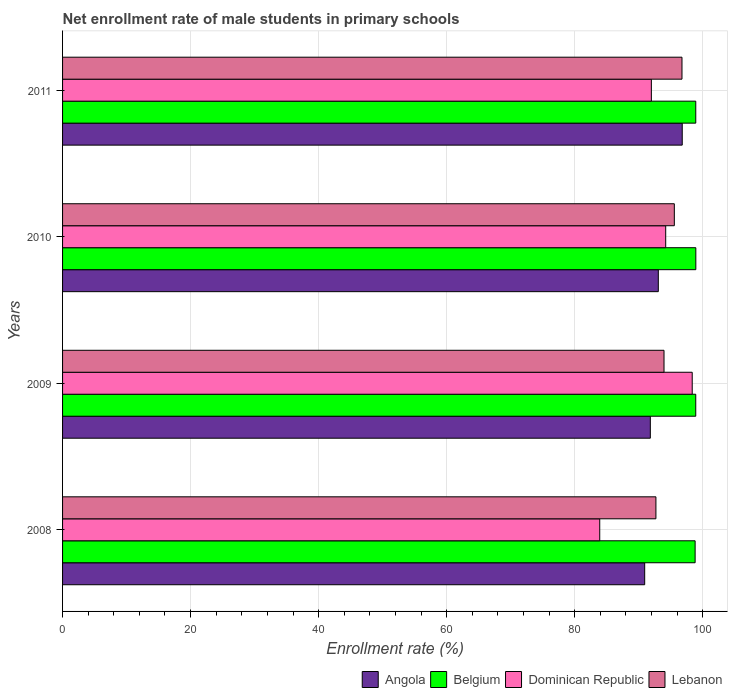How many different coloured bars are there?
Ensure brevity in your answer.  4. Are the number of bars per tick equal to the number of legend labels?
Give a very brief answer. Yes. Are the number of bars on each tick of the Y-axis equal?
Your answer should be compact. Yes. How many bars are there on the 1st tick from the top?
Your answer should be very brief. 4. What is the label of the 4th group of bars from the top?
Ensure brevity in your answer.  2008. In how many cases, is the number of bars for a given year not equal to the number of legend labels?
Ensure brevity in your answer.  0. What is the net enrollment rate of male students in primary schools in Dominican Republic in 2011?
Keep it short and to the point. 91.98. Across all years, what is the maximum net enrollment rate of male students in primary schools in Belgium?
Keep it short and to the point. 98.92. Across all years, what is the minimum net enrollment rate of male students in primary schools in Lebanon?
Your answer should be compact. 92.69. What is the total net enrollment rate of male students in primary schools in Belgium in the graph?
Keep it short and to the point. 395.57. What is the difference between the net enrollment rate of male students in primary schools in Angola in 2009 and that in 2010?
Your response must be concise. -1.25. What is the difference between the net enrollment rate of male students in primary schools in Dominican Republic in 2010 and the net enrollment rate of male students in primary schools in Belgium in 2009?
Keep it short and to the point. -4.69. What is the average net enrollment rate of male students in primary schools in Dominican Republic per year?
Keep it short and to the point. 92.12. In the year 2011, what is the difference between the net enrollment rate of male students in primary schools in Lebanon and net enrollment rate of male students in primary schools in Angola?
Offer a very short reply. -0.04. In how many years, is the net enrollment rate of male students in primary schools in Lebanon greater than 4 %?
Make the answer very short. 4. What is the ratio of the net enrollment rate of male students in primary schools in Dominican Republic in 2008 to that in 2010?
Your answer should be compact. 0.89. What is the difference between the highest and the second highest net enrollment rate of male students in primary schools in Angola?
Give a very brief answer. 3.74. What is the difference between the highest and the lowest net enrollment rate of male students in primary schools in Lebanon?
Give a very brief answer. 4.07. Is the sum of the net enrollment rate of male students in primary schools in Dominican Republic in 2009 and 2011 greater than the maximum net enrollment rate of male students in primary schools in Angola across all years?
Offer a terse response. Yes. What does the 3rd bar from the top in 2011 represents?
Make the answer very short. Belgium. What does the 3rd bar from the bottom in 2008 represents?
Offer a very short reply. Dominican Republic. How many bars are there?
Offer a very short reply. 16. How many years are there in the graph?
Provide a short and direct response. 4. Does the graph contain any zero values?
Ensure brevity in your answer.  No. How are the legend labels stacked?
Your answer should be very brief. Horizontal. What is the title of the graph?
Provide a short and direct response. Net enrollment rate of male students in primary schools. What is the label or title of the X-axis?
Provide a succinct answer. Enrollment rate (%). What is the label or title of the Y-axis?
Keep it short and to the point. Years. What is the Enrollment rate (%) of Angola in 2008?
Offer a very short reply. 90.94. What is the Enrollment rate (%) in Belgium in 2008?
Your answer should be very brief. 98.81. What is the Enrollment rate (%) of Dominican Republic in 2008?
Provide a short and direct response. 83.91. What is the Enrollment rate (%) in Lebanon in 2008?
Your answer should be compact. 92.69. What is the Enrollment rate (%) of Angola in 2009?
Offer a very short reply. 91.82. What is the Enrollment rate (%) of Belgium in 2009?
Your response must be concise. 98.91. What is the Enrollment rate (%) in Dominican Republic in 2009?
Ensure brevity in your answer.  98.36. What is the Enrollment rate (%) of Lebanon in 2009?
Ensure brevity in your answer.  93.96. What is the Enrollment rate (%) of Angola in 2010?
Your answer should be very brief. 93.06. What is the Enrollment rate (%) in Belgium in 2010?
Give a very brief answer. 98.92. What is the Enrollment rate (%) of Dominican Republic in 2010?
Your answer should be compact. 94.22. What is the Enrollment rate (%) in Lebanon in 2010?
Offer a very short reply. 95.56. What is the Enrollment rate (%) in Angola in 2011?
Keep it short and to the point. 96.8. What is the Enrollment rate (%) of Belgium in 2011?
Offer a terse response. 98.91. What is the Enrollment rate (%) in Dominican Republic in 2011?
Offer a very short reply. 91.98. What is the Enrollment rate (%) of Lebanon in 2011?
Provide a succinct answer. 96.76. Across all years, what is the maximum Enrollment rate (%) of Angola?
Offer a very short reply. 96.8. Across all years, what is the maximum Enrollment rate (%) in Belgium?
Offer a terse response. 98.92. Across all years, what is the maximum Enrollment rate (%) of Dominican Republic?
Your answer should be compact. 98.36. Across all years, what is the maximum Enrollment rate (%) in Lebanon?
Provide a succinct answer. 96.76. Across all years, what is the minimum Enrollment rate (%) of Angola?
Make the answer very short. 90.94. Across all years, what is the minimum Enrollment rate (%) in Belgium?
Your response must be concise. 98.81. Across all years, what is the minimum Enrollment rate (%) of Dominican Republic?
Provide a short and direct response. 83.91. Across all years, what is the minimum Enrollment rate (%) in Lebanon?
Offer a very short reply. 92.69. What is the total Enrollment rate (%) of Angola in the graph?
Your response must be concise. 372.62. What is the total Enrollment rate (%) in Belgium in the graph?
Make the answer very short. 395.57. What is the total Enrollment rate (%) of Dominican Republic in the graph?
Provide a succinct answer. 368.47. What is the total Enrollment rate (%) in Lebanon in the graph?
Provide a short and direct response. 378.97. What is the difference between the Enrollment rate (%) of Angola in 2008 and that in 2009?
Provide a short and direct response. -0.88. What is the difference between the Enrollment rate (%) of Belgium in 2008 and that in 2009?
Your response must be concise. -0.1. What is the difference between the Enrollment rate (%) in Dominican Republic in 2008 and that in 2009?
Ensure brevity in your answer.  -14.45. What is the difference between the Enrollment rate (%) in Lebanon in 2008 and that in 2009?
Give a very brief answer. -1.26. What is the difference between the Enrollment rate (%) of Angola in 2008 and that in 2010?
Make the answer very short. -2.13. What is the difference between the Enrollment rate (%) of Belgium in 2008 and that in 2010?
Make the answer very short. -0.11. What is the difference between the Enrollment rate (%) in Dominican Republic in 2008 and that in 2010?
Your response must be concise. -10.31. What is the difference between the Enrollment rate (%) of Lebanon in 2008 and that in 2010?
Offer a very short reply. -2.87. What is the difference between the Enrollment rate (%) of Angola in 2008 and that in 2011?
Your response must be concise. -5.87. What is the difference between the Enrollment rate (%) in Belgium in 2008 and that in 2011?
Provide a succinct answer. -0.1. What is the difference between the Enrollment rate (%) in Dominican Republic in 2008 and that in 2011?
Offer a terse response. -8.07. What is the difference between the Enrollment rate (%) of Lebanon in 2008 and that in 2011?
Keep it short and to the point. -4.07. What is the difference between the Enrollment rate (%) of Angola in 2009 and that in 2010?
Provide a succinct answer. -1.25. What is the difference between the Enrollment rate (%) in Belgium in 2009 and that in 2010?
Your answer should be very brief. -0.01. What is the difference between the Enrollment rate (%) of Dominican Republic in 2009 and that in 2010?
Your answer should be very brief. 4.14. What is the difference between the Enrollment rate (%) of Lebanon in 2009 and that in 2010?
Your answer should be very brief. -1.61. What is the difference between the Enrollment rate (%) in Angola in 2009 and that in 2011?
Ensure brevity in your answer.  -4.98. What is the difference between the Enrollment rate (%) of Belgium in 2009 and that in 2011?
Provide a short and direct response. -0. What is the difference between the Enrollment rate (%) in Dominican Republic in 2009 and that in 2011?
Your answer should be very brief. 6.38. What is the difference between the Enrollment rate (%) of Lebanon in 2009 and that in 2011?
Offer a terse response. -2.81. What is the difference between the Enrollment rate (%) of Angola in 2010 and that in 2011?
Make the answer very short. -3.74. What is the difference between the Enrollment rate (%) of Belgium in 2010 and that in 2011?
Your answer should be compact. 0.01. What is the difference between the Enrollment rate (%) of Dominican Republic in 2010 and that in 2011?
Your answer should be compact. 2.24. What is the difference between the Enrollment rate (%) in Lebanon in 2010 and that in 2011?
Your response must be concise. -1.2. What is the difference between the Enrollment rate (%) of Angola in 2008 and the Enrollment rate (%) of Belgium in 2009?
Your answer should be compact. -7.98. What is the difference between the Enrollment rate (%) in Angola in 2008 and the Enrollment rate (%) in Dominican Republic in 2009?
Give a very brief answer. -7.42. What is the difference between the Enrollment rate (%) of Angola in 2008 and the Enrollment rate (%) of Lebanon in 2009?
Keep it short and to the point. -3.02. What is the difference between the Enrollment rate (%) in Belgium in 2008 and the Enrollment rate (%) in Dominican Republic in 2009?
Provide a short and direct response. 0.45. What is the difference between the Enrollment rate (%) of Belgium in 2008 and the Enrollment rate (%) of Lebanon in 2009?
Provide a short and direct response. 4.86. What is the difference between the Enrollment rate (%) in Dominican Republic in 2008 and the Enrollment rate (%) in Lebanon in 2009?
Make the answer very short. -10.04. What is the difference between the Enrollment rate (%) of Angola in 2008 and the Enrollment rate (%) of Belgium in 2010?
Ensure brevity in your answer.  -7.99. What is the difference between the Enrollment rate (%) in Angola in 2008 and the Enrollment rate (%) in Dominican Republic in 2010?
Your answer should be compact. -3.28. What is the difference between the Enrollment rate (%) of Angola in 2008 and the Enrollment rate (%) of Lebanon in 2010?
Your answer should be very brief. -4.63. What is the difference between the Enrollment rate (%) in Belgium in 2008 and the Enrollment rate (%) in Dominican Republic in 2010?
Provide a short and direct response. 4.6. What is the difference between the Enrollment rate (%) in Belgium in 2008 and the Enrollment rate (%) in Lebanon in 2010?
Keep it short and to the point. 3.25. What is the difference between the Enrollment rate (%) of Dominican Republic in 2008 and the Enrollment rate (%) of Lebanon in 2010?
Ensure brevity in your answer.  -11.65. What is the difference between the Enrollment rate (%) of Angola in 2008 and the Enrollment rate (%) of Belgium in 2011?
Offer a very short reply. -7.98. What is the difference between the Enrollment rate (%) in Angola in 2008 and the Enrollment rate (%) in Dominican Republic in 2011?
Give a very brief answer. -1.04. What is the difference between the Enrollment rate (%) in Angola in 2008 and the Enrollment rate (%) in Lebanon in 2011?
Provide a succinct answer. -5.82. What is the difference between the Enrollment rate (%) of Belgium in 2008 and the Enrollment rate (%) of Dominican Republic in 2011?
Make the answer very short. 6.84. What is the difference between the Enrollment rate (%) in Belgium in 2008 and the Enrollment rate (%) in Lebanon in 2011?
Keep it short and to the point. 2.05. What is the difference between the Enrollment rate (%) of Dominican Republic in 2008 and the Enrollment rate (%) of Lebanon in 2011?
Give a very brief answer. -12.85. What is the difference between the Enrollment rate (%) in Angola in 2009 and the Enrollment rate (%) in Belgium in 2010?
Provide a short and direct response. -7.11. What is the difference between the Enrollment rate (%) in Angola in 2009 and the Enrollment rate (%) in Dominican Republic in 2010?
Your answer should be compact. -2.4. What is the difference between the Enrollment rate (%) of Angola in 2009 and the Enrollment rate (%) of Lebanon in 2010?
Offer a very short reply. -3.75. What is the difference between the Enrollment rate (%) in Belgium in 2009 and the Enrollment rate (%) in Dominican Republic in 2010?
Offer a very short reply. 4.69. What is the difference between the Enrollment rate (%) in Belgium in 2009 and the Enrollment rate (%) in Lebanon in 2010?
Your response must be concise. 3.35. What is the difference between the Enrollment rate (%) in Dominican Republic in 2009 and the Enrollment rate (%) in Lebanon in 2010?
Provide a succinct answer. 2.79. What is the difference between the Enrollment rate (%) of Angola in 2009 and the Enrollment rate (%) of Belgium in 2011?
Keep it short and to the point. -7.1. What is the difference between the Enrollment rate (%) in Angola in 2009 and the Enrollment rate (%) in Dominican Republic in 2011?
Ensure brevity in your answer.  -0.16. What is the difference between the Enrollment rate (%) of Angola in 2009 and the Enrollment rate (%) of Lebanon in 2011?
Keep it short and to the point. -4.94. What is the difference between the Enrollment rate (%) of Belgium in 2009 and the Enrollment rate (%) of Dominican Republic in 2011?
Offer a very short reply. 6.93. What is the difference between the Enrollment rate (%) of Belgium in 2009 and the Enrollment rate (%) of Lebanon in 2011?
Make the answer very short. 2.15. What is the difference between the Enrollment rate (%) in Dominican Republic in 2009 and the Enrollment rate (%) in Lebanon in 2011?
Provide a succinct answer. 1.6. What is the difference between the Enrollment rate (%) in Angola in 2010 and the Enrollment rate (%) in Belgium in 2011?
Provide a succinct answer. -5.85. What is the difference between the Enrollment rate (%) in Angola in 2010 and the Enrollment rate (%) in Dominican Republic in 2011?
Provide a short and direct response. 1.09. What is the difference between the Enrollment rate (%) of Angola in 2010 and the Enrollment rate (%) of Lebanon in 2011?
Ensure brevity in your answer.  -3.7. What is the difference between the Enrollment rate (%) of Belgium in 2010 and the Enrollment rate (%) of Dominican Republic in 2011?
Ensure brevity in your answer.  6.95. What is the difference between the Enrollment rate (%) in Belgium in 2010 and the Enrollment rate (%) in Lebanon in 2011?
Offer a very short reply. 2.16. What is the difference between the Enrollment rate (%) in Dominican Republic in 2010 and the Enrollment rate (%) in Lebanon in 2011?
Offer a very short reply. -2.54. What is the average Enrollment rate (%) of Angola per year?
Your answer should be very brief. 93.15. What is the average Enrollment rate (%) of Belgium per year?
Keep it short and to the point. 98.89. What is the average Enrollment rate (%) in Dominican Republic per year?
Make the answer very short. 92.12. What is the average Enrollment rate (%) of Lebanon per year?
Offer a terse response. 94.74. In the year 2008, what is the difference between the Enrollment rate (%) in Angola and Enrollment rate (%) in Belgium?
Keep it short and to the point. -7.88. In the year 2008, what is the difference between the Enrollment rate (%) of Angola and Enrollment rate (%) of Dominican Republic?
Make the answer very short. 7.02. In the year 2008, what is the difference between the Enrollment rate (%) of Angola and Enrollment rate (%) of Lebanon?
Make the answer very short. -1.76. In the year 2008, what is the difference between the Enrollment rate (%) of Belgium and Enrollment rate (%) of Dominican Republic?
Your answer should be compact. 14.9. In the year 2008, what is the difference between the Enrollment rate (%) of Belgium and Enrollment rate (%) of Lebanon?
Your answer should be very brief. 6.12. In the year 2008, what is the difference between the Enrollment rate (%) in Dominican Republic and Enrollment rate (%) in Lebanon?
Your response must be concise. -8.78. In the year 2009, what is the difference between the Enrollment rate (%) in Angola and Enrollment rate (%) in Belgium?
Offer a very short reply. -7.1. In the year 2009, what is the difference between the Enrollment rate (%) of Angola and Enrollment rate (%) of Dominican Republic?
Offer a very short reply. -6.54. In the year 2009, what is the difference between the Enrollment rate (%) of Angola and Enrollment rate (%) of Lebanon?
Keep it short and to the point. -2.14. In the year 2009, what is the difference between the Enrollment rate (%) of Belgium and Enrollment rate (%) of Dominican Republic?
Your response must be concise. 0.55. In the year 2009, what is the difference between the Enrollment rate (%) of Belgium and Enrollment rate (%) of Lebanon?
Provide a short and direct response. 4.96. In the year 2009, what is the difference between the Enrollment rate (%) in Dominican Republic and Enrollment rate (%) in Lebanon?
Your answer should be compact. 4.4. In the year 2010, what is the difference between the Enrollment rate (%) of Angola and Enrollment rate (%) of Belgium?
Offer a terse response. -5.86. In the year 2010, what is the difference between the Enrollment rate (%) in Angola and Enrollment rate (%) in Dominican Republic?
Your answer should be very brief. -1.16. In the year 2010, what is the difference between the Enrollment rate (%) of Angola and Enrollment rate (%) of Lebanon?
Give a very brief answer. -2.5. In the year 2010, what is the difference between the Enrollment rate (%) of Belgium and Enrollment rate (%) of Dominican Republic?
Your response must be concise. 4.71. In the year 2010, what is the difference between the Enrollment rate (%) in Belgium and Enrollment rate (%) in Lebanon?
Offer a terse response. 3.36. In the year 2010, what is the difference between the Enrollment rate (%) in Dominican Republic and Enrollment rate (%) in Lebanon?
Provide a short and direct response. -1.35. In the year 2011, what is the difference between the Enrollment rate (%) in Angola and Enrollment rate (%) in Belgium?
Offer a terse response. -2.11. In the year 2011, what is the difference between the Enrollment rate (%) in Angola and Enrollment rate (%) in Dominican Republic?
Provide a succinct answer. 4.82. In the year 2011, what is the difference between the Enrollment rate (%) of Angola and Enrollment rate (%) of Lebanon?
Keep it short and to the point. 0.04. In the year 2011, what is the difference between the Enrollment rate (%) of Belgium and Enrollment rate (%) of Dominican Republic?
Offer a very short reply. 6.94. In the year 2011, what is the difference between the Enrollment rate (%) in Belgium and Enrollment rate (%) in Lebanon?
Give a very brief answer. 2.15. In the year 2011, what is the difference between the Enrollment rate (%) in Dominican Republic and Enrollment rate (%) in Lebanon?
Your answer should be compact. -4.78. What is the ratio of the Enrollment rate (%) of Angola in 2008 to that in 2009?
Your answer should be very brief. 0.99. What is the ratio of the Enrollment rate (%) in Dominican Republic in 2008 to that in 2009?
Provide a short and direct response. 0.85. What is the ratio of the Enrollment rate (%) of Lebanon in 2008 to that in 2009?
Offer a very short reply. 0.99. What is the ratio of the Enrollment rate (%) in Angola in 2008 to that in 2010?
Your answer should be compact. 0.98. What is the ratio of the Enrollment rate (%) in Belgium in 2008 to that in 2010?
Keep it short and to the point. 1. What is the ratio of the Enrollment rate (%) in Dominican Republic in 2008 to that in 2010?
Give a very brief answer. 0.89. What is the ratio of the Enrollment rate (%) of Lebanon in 2008 to that in 2010?
Give a very brief answer. 0.97. What is the ratio of the Enrollment rate (%) of Angola in 2008 to that in 2011?
Give a very brief answer. 0.94. What is the ratio of the Enrollment rate (%) of Belgium in 2008 to that in 2011?
Give a very brief answer. 1. What is the ratio of the Enrollment rate (%) of Dominican Republic in 2008 to that in 2011?
Your answer should be very brief. 0.91. What is the ratio of the Enrollment rate (%) of Lebanon in 2008 to that in 2011?
Your answer should be very brief. 0.96. What is the ratio of the Enrollment rate (%) of Angola in 2009 to that in 2010?
Your answer should be very brief. 0.99. What is the ratio of the Enrollment rate (%) of Dominican Republic in 2009 to that in 2010?
Offer a very short reply. 1.04. What is the ratio of the Enrollment rate (%) of Lebanon in 2009 to that in 2010?
Offer a very short reply. 0.98. What is the ratio of the Enrollment rate (%) of Angola in 2009 to that in 2011?
Give a very brief answer. 0.95. What is the ratio of the Enrollment rate (%) in Dominican Republic in 2009 to that in 2011?
Your answer should be very brief. 1.07. What is the ratio of the Enrollment rate (%) of Angola in 2010 to that in 2011?
Give a very brief answer. 0.96. What is the ratio of the Enrollment rate (%) in Belgium in 2010 to that in 2011?
Give a very brief answer. 1. What is the ratio of the Enrollment rate (%) of Dominican Republic in 2010 to that in 2011?
Offer a terse response. 1.02. What is the ratio of the Enrollment rate (%) in Lebanon in 2010 to that in 2011?
Ensure brevity in your answer.  0.99. What is the difference between the highest and the second highest Enrollment rate (%) of Angola?
Keep it short and to the point. 3.74. What is the difference between the highest and the second highest Enrollment rate (%) of Belgium?
Your answer should be very brief. 0.01. What is the difference between the highest and the second highest Enrollment rate (%) of Dominican Republic?
Make the answer very short. 4.14. What is the difference between the highest and the second highest Enrollment rate (%) in Lebanon?
Ensure brevity in your answer.  1.2. What is the difference between the highest and the lowest Enrollment rate (%) in Angola?
Provide a succinct answer. 5.87. What is the difference between the highest and the lowest Enrollment rate (%) in Belgium?
Provide a short and direct response. 0.11. What is the difference between the highest and the lowest Enrollment rate (%) in Dominican Republic?
Provide a short and direct response. 14.45. What is the difference between the highest and the lowest Enrollment rate (%) in Lebanon?
Provide a succinct answer. 4.07. 